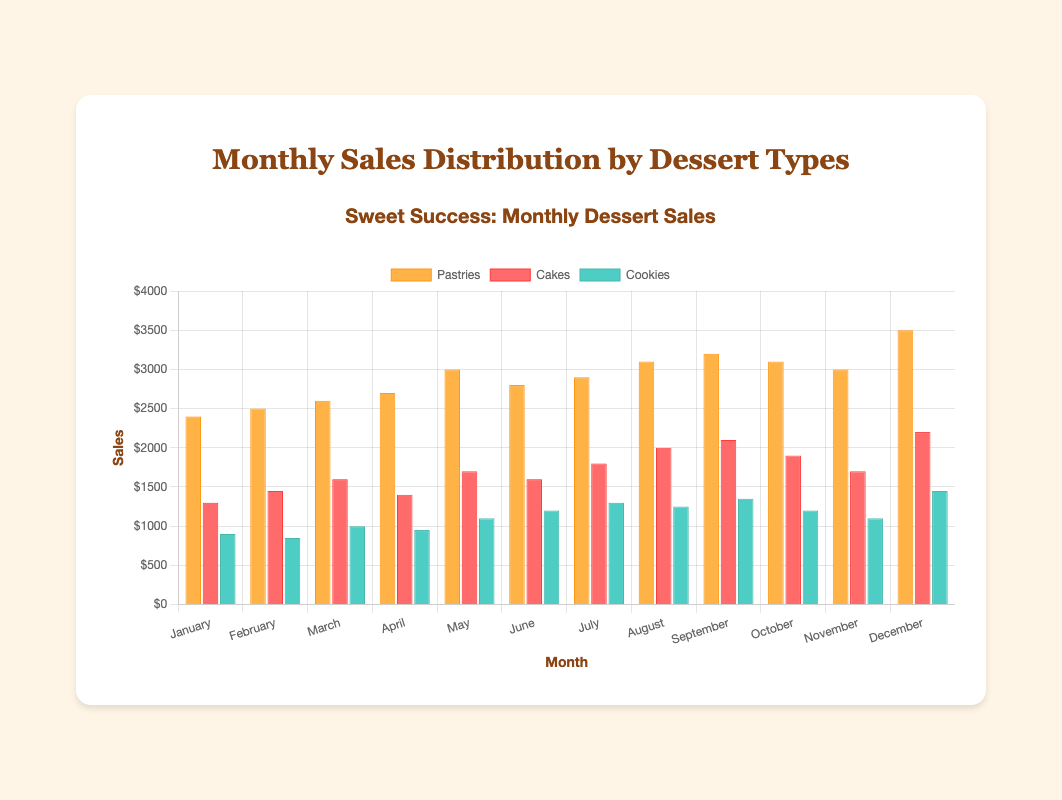What month had the highest sales for pastries? The highest sales for pastries can be found by comparing the values for each month. The value for December is the highest at 3500.
Answer: December Comparing July and August, which month had higher cookie sales? Comparing the sales of cookies in July (1300) and August (1250), the sales were higher in July.
Answer: July What is the total sales of cakes in the first quarter (January, February, March)? Sum the sales of cakes in January, February, and March: 1300 + 1450 + 1600 = 4350.
Answer: 4350 Which dessert type had the least sales in April? By comparing the sales for April: Pastries (2700), Cakes (1400), Cookies (950), the least sales were for cookies.
Answer: Cookies What was the total sales of all desserts combined in December? Sum the sales of all dessert types in December: Pastries (3500) + Cakes (2200) + Cookies (1450) = 7150.
Answer: 7150 Between March and June, in which month were cake sales equal? The cake sales in March (1600) and June (1600) are the same.
Answer: March and June Which month showed a greater increase in pastry sales compared to its previous month: June to July or November to December? Calculate the difference in sales: 
- June to July: 2900 - 2800 = 100
- November to December: 3500 - 3000 = 500
The increase is greater from November to December.
Answer: November to December What is the average monthly sales for cookies across the year? Sum all cookie sales and divide by 12: (900 + 850 + 1000 + 950 + 1100 + 1200 + 1300 + 1250 + 1350 + 1200 + 1100 + 1450) / 12 = 1200.
Answer: 1200 Which month had the highest total sales across all dessert types? Sum the sales for each month:
- January: 2400 + 1300 + 900 = 4600
- February: 2500 + 1450 + 850 = 4800
- March: 2600 + 1600 + 1000 = 5200
- April: 2700 + 1400 + 950 = 5050
- May: 3000 + 1700 + 1100 = 5800
- June: 2800 + 1600 + 1200 = 5600
- July: 2900 + 1800 + 1300 = 6000
- August: 3100 + 2000 + 1250 = 6350
- September: 3200 + 2100 + 1350 = 6650
- October: 3100 + 1900 + 1200 = 6200
- November: 3000 + 1700 + 1100 = 5800
- December: 3500 + 2200 + 1450 = 7150
December had the highest total sales of 7150.
Answer: December Throughout the year, which type of dessert shows the most notable trend (increase or decrease in sales)? Pastries show a notable increasing trend from January’s sales (2400) consistently up to December (3500), with slight variations.
Answer: Pastries 